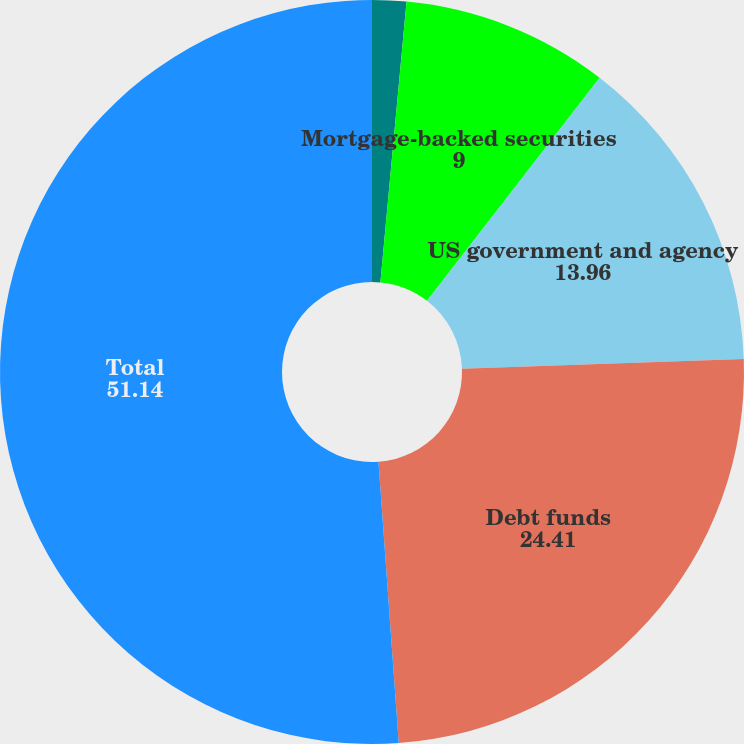<chart> <loc_0><loc_0><loc_500><loc_500><pie_chart><fcel>Corporate debt securities<fcel>Mortgage-backed securities<fcel>US government and agency<fcel>Debt funds<fcel>Total<nl><fcel>1.48%<fcel>9.0%<fcel>13.96%<fcel>24.41%<fcel>51.14%<nl></chart> 